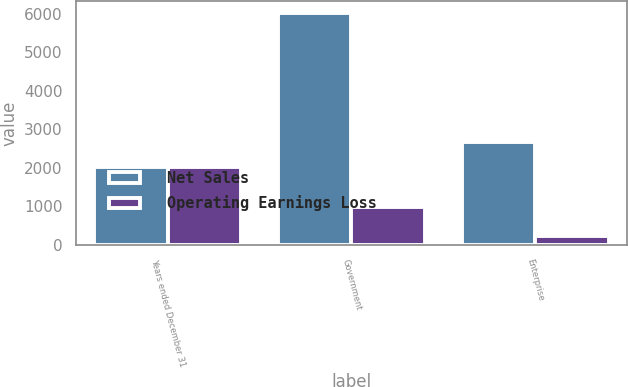<chart> <loc_0><loc_0><loc_500><loc_500><stacked_bar_chart><ecel><fcel>Years ended December 31<fcel>Government<fcel>Enterprise<nl><fcel>Net Sales<fcel>2013<fcel>6030<fcel>2666<nl><fcel>Operating Earnings Loss<fcel>2013<fcel>979<fcel>236<nl></chart> 